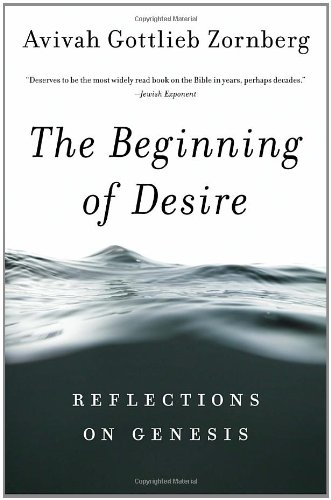What is the title of this book? 'The Beginning of Desire: Reflections on Genesis' is the title, suggesting an introspective exploration into the first book of the Bible, focusing on themes of desire and beginning. 